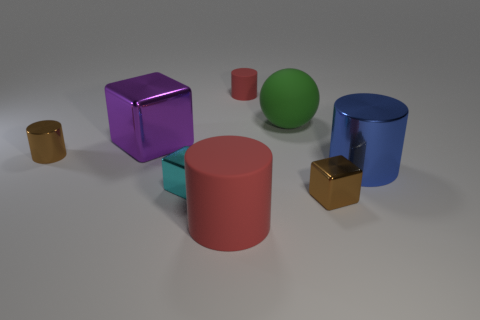Subtract 1 cylinders. How many cylinders are left? 3 Subtract all green cylinders. Subtract all blue balls. How many cylinders are left? 4 Add 2 big red rubber objects. How many objects exist? 10 Subtract all cubes. How many objects are left? 5 Add 8 red cylinders. How many red cylinders are left? 10 Add 1 cyan rubber things. How many cyan rubber things exist? 1 Subtract 1 blue cylinders. How many objects are left? 7 Subtract all red matte spheres. Subtract all tiny shiny cylinders. How many objects are left? 7 